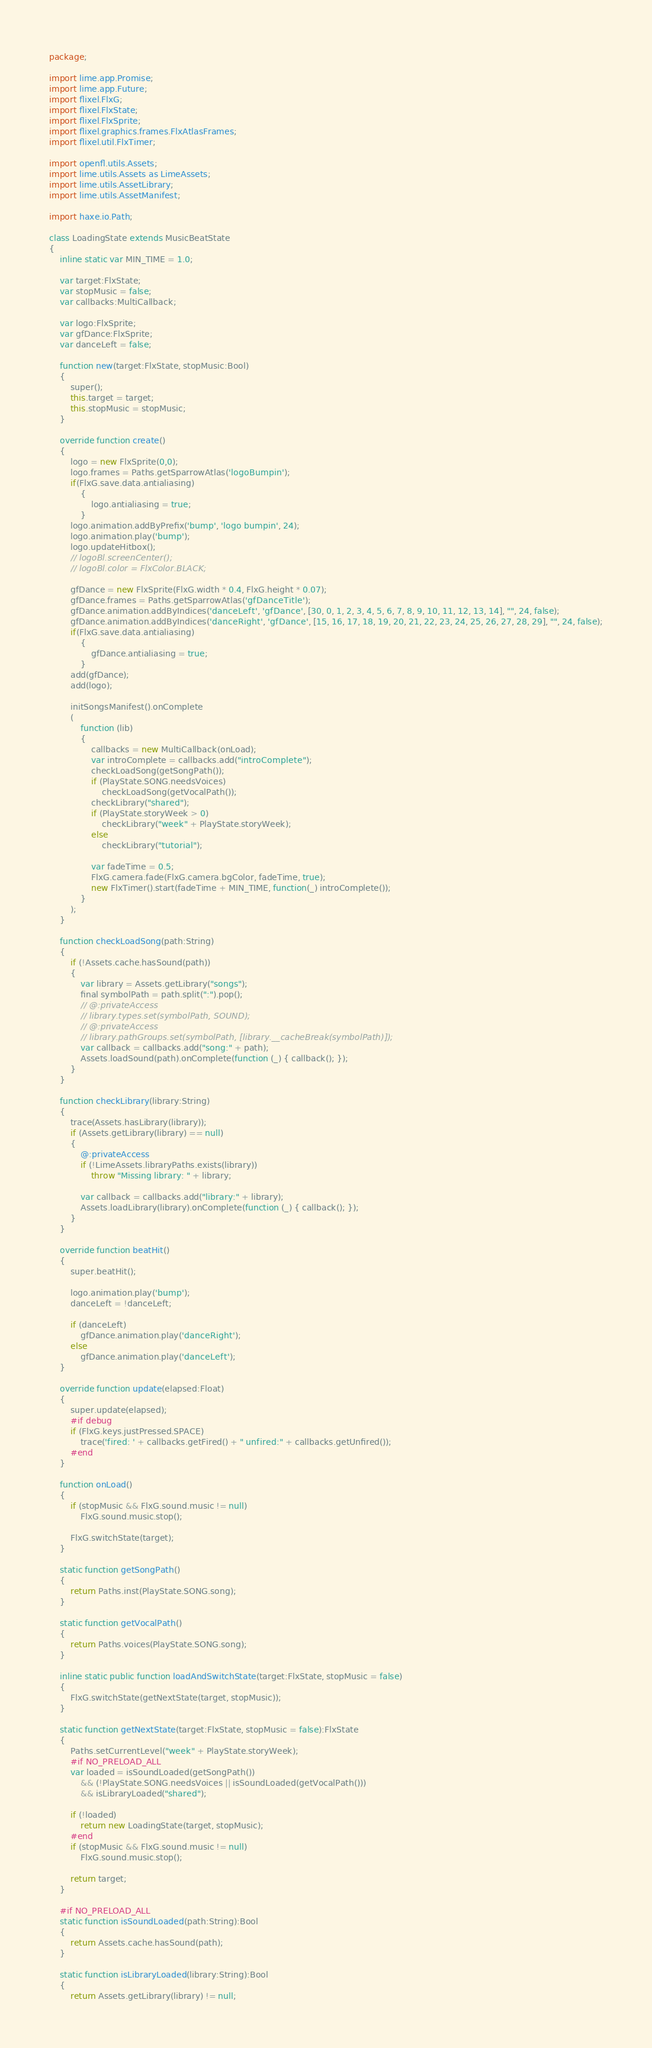Convert code to text. <code><loc_0><loc_0><loc_500><loc_500><_Haxe_>package;

import lime.app.Promise;
import lime.app.Future;
import flixel.FlxG;
import flixel.FlxState;
import flixel.FlxSprite;
import flixel.graphics.frames.FlxAtlasFrames;
import flixel.util.FlxTimer;

import openfl.utils.Assets;
import lime.utils.Assets as LimeAssets;
import lime.utils.AssetLibrary;
import lime.utils.AssetManifest;

import haxe.io.Path;

class LoadingState extends MusicBeatState
{
	inline static var MIN_TIME = 1.0;
	
	var target:FlxState;
	var stopMusic = false;
	var callbacks:MultiCallback;
	
	var logo:FlxSprite;
	var gfDance:FlxSprite;
	var danceLeft = false;
	
	function new(target:FlxState, stopMusic:Bool)
	{
		super();
		this.target = target;
		this.stopMusic = stopMusic;
	}
	
	override function create()
	{
		logo = new FlxSprite(0,0);
		logo.frames = Paths.getSparrowAtlas('logoBumpin');
		if(FlxG.save.data.antialiasing)
			{
				logo.antialiasing = true;
			}
		logo.animation.addByPrefix('bump', 'logo bumpin', 24);
		logo.animation.play('bump');
		logo.updateHitbox();
		// logoBl.screenCenter();
		// logoBl.color = FlxColor.BLACK;

		gfDance = new FlxSprite(FlxG.width * 0.4, FlxG.height * 0.07);
		gfDance.frames = Paths.getSparrowAtlas('gfDanceTitle');
		gfDance.animation.addByIndices('danceLeft', 'gfDance', [30, 0, 1, 2, 3, 4, 5, 6, 7, 8, 9, 10, 11, 12, 13, 14], "", 24, false);
		gfDance.animation.addByIndices('danceRight', 'gfDance', [15, 16, 17, 18, 19, 20, 21, 22, 23, 24, 25, 26, 27, 28, 29], "", 24, false);
		if(FlxG.save.data.antialiasing)
			{
				gfDance.antialiasing = true;
			}
		add(gfDance);
		add(logo);
		
		initSongsManifest().onComplete
		(
			function (lib)
			{
				callbacks = new MultiCallback(onLoad);
				var introComplete = callbacks.add("introComplete");
				checkLoadSong(getSongPath());
				if (PlayState.SONG.needsVoices)
					checkLoadSong(getVocalPath());
				checkLibrary("shared");
				if (PlayState.storyWeek > 0)
					checkLibrary("week" + PlayState.storyWeek);
				else
					checkLibrary("tutorial");
				
				var fadeTime = 0.5;
				FlxG.camera.fade(FlxG.camera.bgColor, fadeTime, true);
				new FlxTimer().start(fadeTime + MIN_TIME, function(_) introComplete());
			}
		);
	}
	
	function checkLoadSong(path:String)
	{
		if (!Assets.cache.hasSound(path))
		{
			var library = Assets.getLibrary("songs");
			final symbolPath = path.split(":").pop();
			// @:privateAccess
			// library.types.set(symbolPath, SOUND);
			// @:privateAccess
			// library.pathGroups.set(symbolPath, [library.__cacheBreak(symbolPath)]);
			var callback = callbacks.add("song:" + path);
			Assets.loadSound(path).onComplete(function (_) { callback(); });
		}
	}
	
	function checkLibrary(library:String)
	{
		trace(Assets.hasLibrary(library));
		if (Assets.getLibrary(library) == null)
		{
			@:privateAccess
			if (!LimeAssets.libraryPaths.exists(library))
				throw "Missing library: " + library;
			
			var callback = callbacks.add("library:" + library);
			Assets.loadLibrary(library).onComplete(function (_) { callback(); });
		}
	}
	
	override function beatHit()
	{
		super.beatHit();
		
		logo.animation.play('bump');
		danceLeft = !danceLeft;
		
		if (danceLeft)
			gfDance.animation.play('danceRight');
		else
			gfDance.animation.play('danceLeft');
	}
	
	override function update(elapsed:Float)
	{
		super.update(elapsed);
		#if debug
		if (FlxG.keys.justPressed.SPACE)
			trace('fired: ' + callbacks.getFired() + " unfired:" + callbacks.getUnfired());
		#end
	}
	
	function onLoad()
	{
		if (stopMusic && FlxG.sound.music != null)
			FlxG.sound.music.stop();
		
		FlxG.switchState(target);
	}
	
	static function getSongPath()
	{
		return Paths.inst(PlayState.SONG.song);
	}
	
	static function getVocalPath()
	{
		return Paths.voices(PlayState.SONG.song);
	}
	
	inline static public function loadAndSwitchState(target:FlxState, stopMusic = false)
	{
		FlxG.switchState(getNextState(target, stopMusic));
	}
	
	static function getNextState(target:FlxState, stopMusic = false):FlxState
	{
		Paths.setCurrentLevel("week" + PlayState.storyWeek);
		#if NO_PRELOAD_ALL
		var loaded = isSoundLoaded(getSongPath())
			&& (!PlayState.SONG.needsVoices || isSoundLoaded(getVocalPath()))
			&& isLibraryLoaded("shared");
		
		if (!loaded)
			return new LoadingState(target, stopMusic);
		#end
		if (stopMusic && FlxG.sound.music != null)
			FlxG.sound.music.stop();
		
		return target;
	}
	
	#if NO_PRELOAD_ALL
	static function isSoundLoaded(path:String):Bool
	{
		return Assets.cache.hasSound(path);
	}
	
	static function isLibraryLoaded(library:String):Bool
	{
		return Assets.getLibrary(library) != null;</code> 